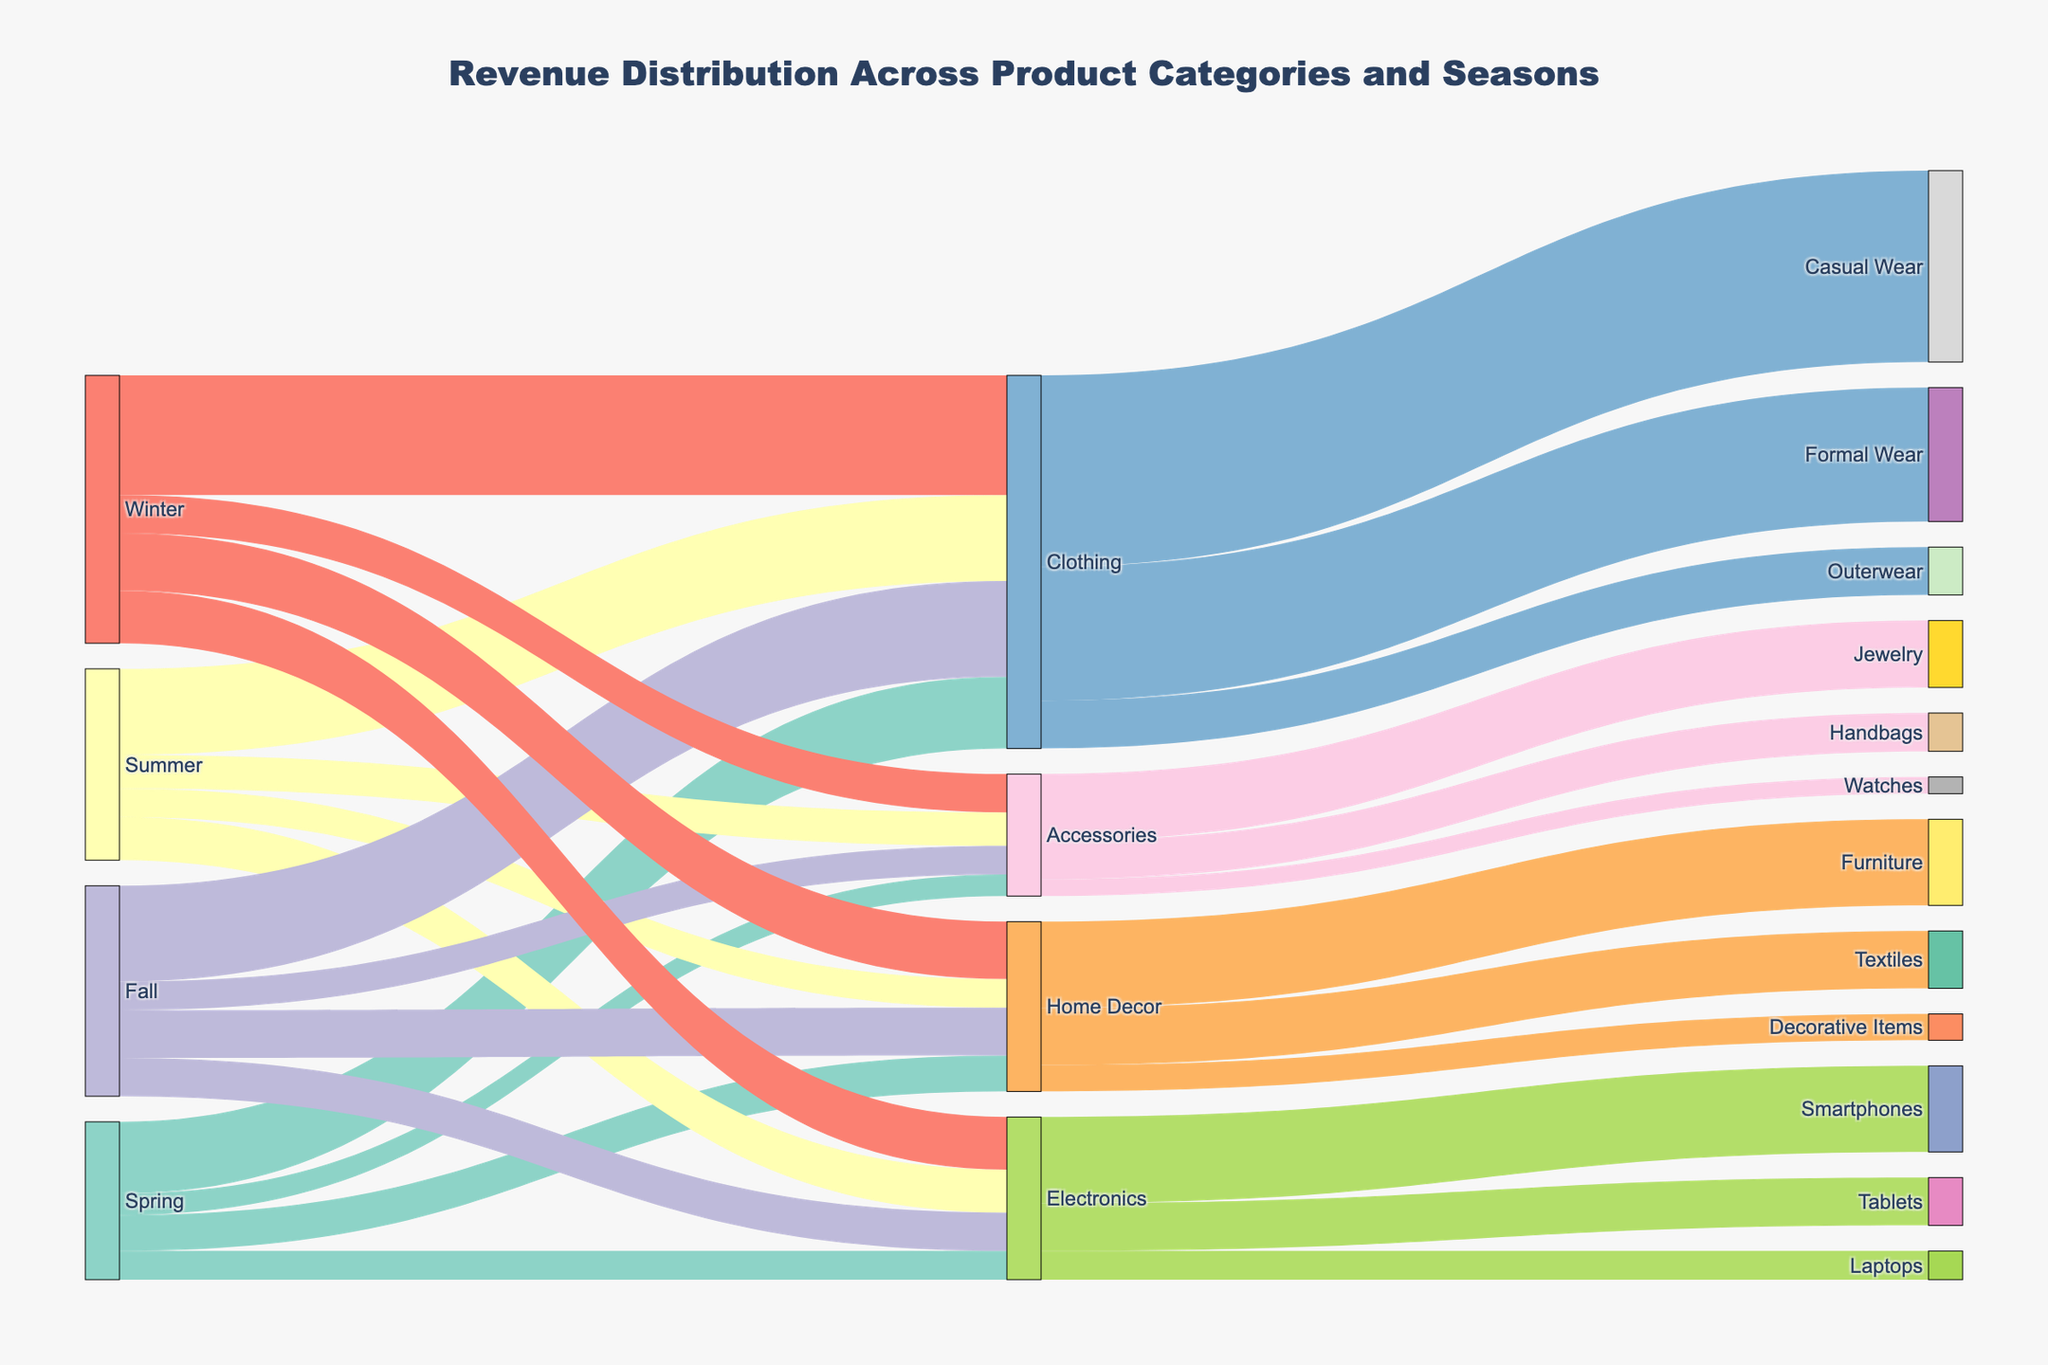What is the title of the Sankey diagram? The title of the diagram is typically displayed at the top of the figure. In this case, it consolidates the context of the figure, which comes from the code that creates it.
Answer: Revenue Distribution Across Product Categories and Seasons Which season contributes the most revenue to the Clothing category? Look at the links from each season to the Clothing category and identify the one with the highest value. Winter contributes $250,000.
Answer: Winter What is the total revenue generated from Home Decor across all seasons? Summing up the values from each season to Home Decor: $75,000 (Spring) + $60,000 (Summer) + $100,000 (Fall) + $120,000 (Winter) = $355,000.
Answer: $355,000 How much more revenue does Accessories generate in Winter compared to Spring? Subtract the value of Accessories in Spring from the value in Winter: $80,000 (Winter) - $45,000 (Spring) = $35,000.
Answer: $35,000 Which product category has the highest single revenue contribution, and what is its value? The highest revenue contribution can be identified by the largest value within the links. From Winter to Clothing, it is $250,000.
Answer: Clothing with $250,000 What is the total revenue for Electronics in Summer compared to Fall? Summing up values for Electronics: Summer $90,000 + Fall $80,000 = $170,000.
Answer: $170,000 Which subcategory within Electronics has the lowest revenue, and what is its value? From the target values branching from Electronics, identifying the smallest value: Laptops with $60,000.
Answer: Laptops with $60,000 What percentage of the total revenue does Formal Wear contribute to the Clothing category? Calculate the total Clothing revenue and the contribution of Formal Wear: (Formal Wear $280,000 / Total Clothing $780,000) * 100 = ~35.9%.
Answer: ~35.9% Compare the total revenue of Jewelry in Accessories to that of Smartphones in Electronics. Which one is higher and by how much? Sum the revenues of Jewelry within Accessories and Smartphones within Electronics, then compare: Smartphones $180,000 - Jewelry $140,000 = $40,000.
Answer: Smartphones by $40,000 